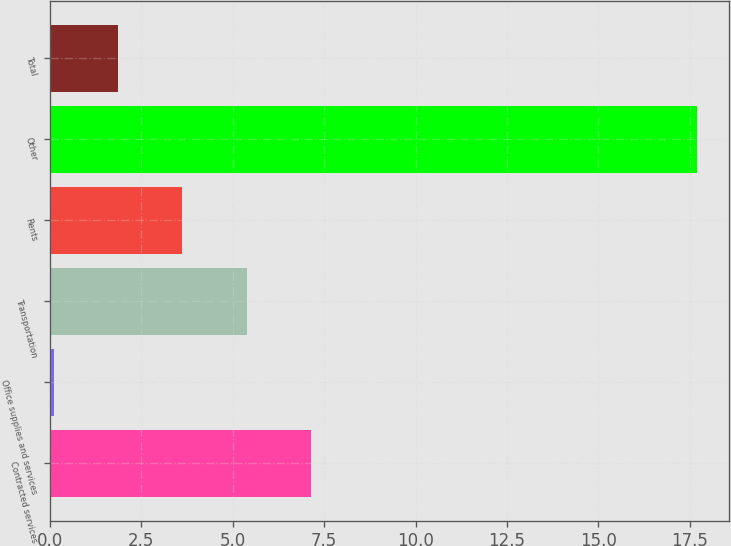Convert chart to OTSL. <chart><loc_0><loc_0><loc_500><loc_500><bar_chart><fcel>Contracted services<fcel>Office supplies and services<fcel>Transportation<fcel>Rents<fcel>Other<fcel>Total<nl><fcel>7.14<fcel>0.1<fcel>5.38<fcel>3.62<fcel>17.7<fcel>1.86<nl></chart> 